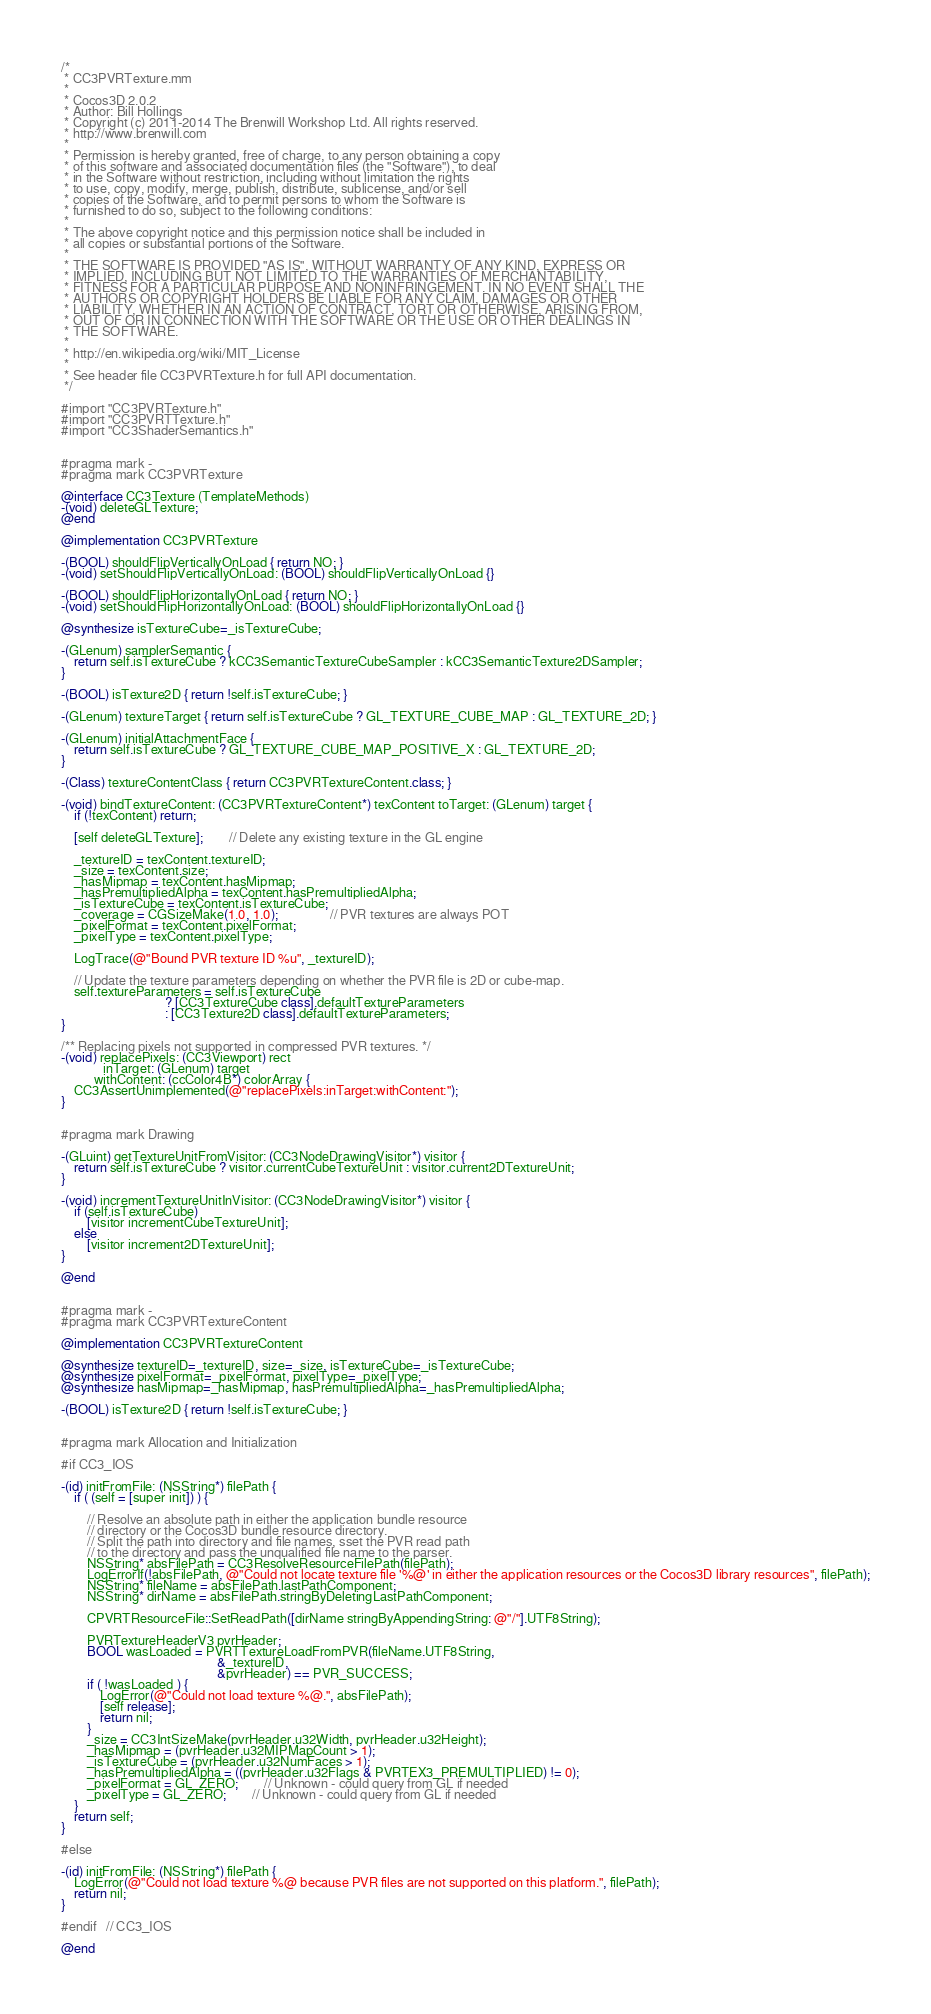Convert code to text. <code><loc_0><loc_0><loc_500><loc_500><_ObjectiveC_>/*
 * CC3PVRTexture.mm
 *
 * Cocos3D 2.0.2
 * Author: Bill Hollings
 * Copyright (c) 2011-2014 The Brenwill Workshop Ltd. All rights reserved.
 * http://www.brenwill.com
 *
 * Permission is hereby granted, free of charge, to any person obtaining a copy
 * of this software and associated documentation files (the "Software"), to deal
 * in the Software without restriction, including without limitation the rights
 * to use, copy, modify, merge, publish, distribute, sublicense, and/or sell
 * copies of the Software, and to permit persons to whom the Software is
 * furnished to do so, subject to the following conditions:
 * 
 * The above copyright notice and this permission notice shall be included in
 * all copies or substantial portions of the Software.
 *
 * THE SOFTWARE IS PROVIDED "AS IS", WITHOUT WARRANTY OF ANY KIND, EXPRESS OR
 * IMPLIED, INCLUDING BUT NOT LIMITED TO THE WARRANTIES OF MERCHANTABILITY,
 * FITNESS FOR A PARTICULAR PURPOSE AND NONINFRINGEMENT. IN NO EVENT SHALL THE
 * AUTHORS OR COPYRIGHT HOLDERS BE LIABLE FOR ANY CLAIM, DAMAGES OR OTHER
 * LIABILITY, WHETHER IN AN ACTION OF CONTRACT, TORT OR OTHERWISE, ARISING FROM,
 * OUT OF OR IN CONNECTION WITH THE SOFTWARE OR THE USE OR OTHER DEALINGS IN
 * THE SOFTWARE.
 *
 * http://en.wikipedia.org/wiki/MIT_License
 * 
 * See header file CC3PVRTexture.h for full API documentation.
 */

#import "CC3PVRTexture.h"
#import "CC3PVRTTexture.h"
#import "CC3ShaderSemantics.h"


#pragma mark -
#pragma mark CC3PVRTexture

@interface CC3Texture (TemplateMethods)
-(void) deleteGLTexture;
@end

@implementation CC3PVRTexture

-(BOOL) shouldFlipVerticallyOnLoad { return NO; }
-(void) setShouldFlipVerticallyOnLoad: (BOOL) shouldFlipVerticallyOnLoad {}

-(BOOL) shouldFlipHorizontallyOnLoad { return NO; }
-(void) setShouldFlipHorizontallyOnLoad: (BOOL) shouldFlipHorizontallyOnLoad {}

@synthesize isTextureCube=_isTextureCube;

-(GLenum) samplerSemantic {
	return self.isTextureCube ? kCC3SemanticTextureCubeSampler : kCC3SemanticTexture2DSampler;
}

-(BOOL) isTexture2D { return !self.isTextureCube; }

-(GLenum) textureTarget { return self.isTextureCube ? GL_TEXTURE_CUBE_MAP : GL_TEXTURE_2D; }

-(GLenum) initialAttachmentFace {
	return self.isTextureCube ? GL_TEXTURE_CUBE_MAP_POSITIVE_X : GL_TEXTURE_2D;
}

-(Class) textureContentClass { return CC3PVRTextureContent.class; }

-(void) bindTextureContent: (CC3PVRTextureContent*) texContent toTarget: (GLenum) target {
	if (!texContent) return;
	
	[self deleteGLTexture];		// Delete any existing texture in the GL engine
	
	_textureID = texContent.textureID;
	_size = texContent.size;
	_hasMipmap = texContent.hasMipmap;
	_hasPremultipliedAlpha = texContent.hasPremultipliedAlpha;
	_isTextureCube = texContent.isTextureCube;
	_coverage = CGSizeMake(1.0, 1.0);				// PVR textures are always POT
	_pixelFormat = texContent.pixelFormat;
	_pixelType = texContent.pixelType;
	
	LogTrace(@"Bound PVR texture ID %u", _textureID);
	
	// Update the texture parameters depending on whether the PVR file is 2D or cube-map.
	self.textureParameters = self.isTextureCube
								? [CC3TextureCube class].defaultTextureParameters
								: [CC3Texture2D class].defaultTextureParameters;
}

/** Replacing pixels not supported in compressed PVR textures. */
-(void) replacePixels: (CC3Viewport) rect
			 inTarget: (GLenum) target
		  withContent: (ccColor4B*) colorArray {
	CC3AssertUnimplemented(@"replacePixels:inTarget:withContent:");
}


#pragma mark Drawing

-(GLuint) getTextureUnitFromVisitor: (CC3NodeDrawingVisitor*) visitor {
	return self.isTextureCube ? visitor.currentCubeTextureUnit : visitor.current2DTextureUnit;
}

-(void) incrementTextureUnitInVisitor: (CC3NodeDrawingVisitor*) visitor {
	if (self.isTextureCube)
		[visitor incrementCubeTextureUnit];
	else
		[visitor increment2DTextureUnit];
}

@end


#pragma mark -
#pragma mark CC3PVRTextureContent

@implementation CC3PVRTextureContent

@synthesize textureID=_textureID, size=_size, isTextureCube=_isTextureCube;
@synthesize pixelFormat=_pixelFormat, pixelType=_pixelType;
@synthesize hasMipmap=_hasMipmap, hasPremultipliedAlpha=_hasPremultipliedAlpha;

-(BOOL) isTexture2D { return !self.isTextureCube; }


#pragma mark Allocation and Initialization

#if CC3_IOS

-(id) initFromFile: (NSString*) filePath {
	if ( (self = [super init]) ) {
		
		// Resolve an absolute path in either the application bundle resource
		// directory or the Cocos3D bundle resource directory.
		// Split the path into directory and file names, sset the PVR read path
		// to the directory and pass the unqualified file name to the parser.
		NSString* absFilePath = CC3ResolveResourceFilePath(filePath);
		LogErrorIf(!absFilePath, @"Could not locate texture file '%@' in either the application resources or the Cocos3D library resources", filePath);
		NSString* fileName = absFilePath.lastPathComponent;
		NSString* dirName = absFilePath.stringByDeletingLastPathComponent;
		
		CPVRTResourceFile::SetReadPath([dirName stringByAppendingString: @"/"].UTF8String);
		
		PVRTextureHeaderV3 pvrHeader;
		BOOL wasLoaded = PVRTTextureLoadFromPVR(fileName.UTF8String,
												&_textureID,
												&pvrHeader) == PVR_SUCCESS;
		if ( !wasLoaded ) {
			LogError(@"Could not load texture %@.", absFilePath);
			[self release];
			return nil;
		}
		_size = CC3IntSizeMake(pvrHeader.u32Width, pvrHeader.u32Height);
		_hasMipmap = (pvrHeader.u32MIPMapCount > 1);
		_isTextureCube = (pvrHeader.u32NumFaces > 1);
		_hasPremultipliedAlpha = ((pvrHeader.u32Flags & PVRTEX3_PREMULTIPLIED) != 0);
		_pixelFormat = GL_ZERO;		// Unknown - could query from GL if needed
		_pixelType = GL_ZERO;		// Unknown - could query from GL if needed
	}
	return self;
}

#else

-(id) initFromFile: (NSString*) filePath {
	LogError(@"Could not load texture %@ because PVR files are not supported on this platform.", filePath);
	return nil;
}

#endif	// CC3_IOS

@end
</code> 